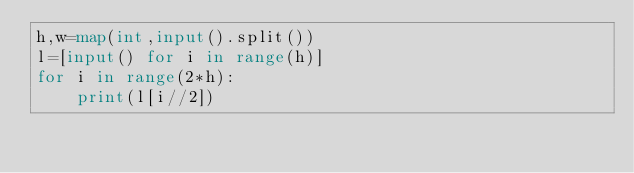<code> <loc_0><loc_0><loc_500><loc_500><_Python_>h,w=map(int,input().split())
l=[input() for i in range(h)]
for i in range(2*h):
    print(l[i//2])</code> 